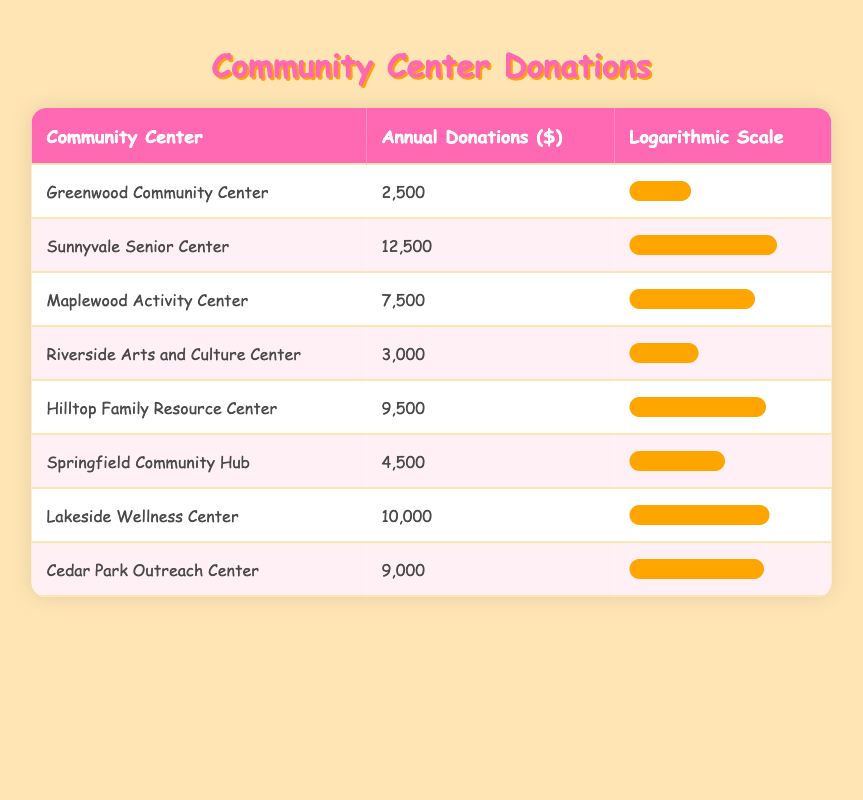What is the annual donation amount for the Sunnyvale Senior Center? The table explicitly lists the Sunnyvale Senior Center with an annual donation of 12,500 dollars
Answer: 12,500 Which community center received the least annual donations? The Greenwood Community Center has the lowest annual donation amount in the table, which is 2,500 dollars
Answer: 2,500 What is the total annual donations received by all the community centers? To calculate the total, we sum up the annual donations: 2,500 + 12,500 + 7,500 + 3,000 + 9,500 + 4,500 + 10,000 + 9,000 = 58,500 dollars
Answer: 58,500 Is the Riverside Arts and Culture Center's annual donation greater than or equal to the Cedar Park Outreach Center's donations? Riverside Arts and Culture Center received 3,000 dollars while Cedar Park Outreach Center received 9,000 dollars, so the statement is false
Answer: No What is the average annual donation of the community centers? To find the average, we first sum the annual donations (58,500) and divide by the number of community centers (8). Therefore, 58,500 / 8 = 7,312.5 dollars
Answer: 7,312.5 Which community center has donations closest to the average? The average is 7,312.5 dollars; comparing each center's donations, Maplewood Activity Center at 7,500 dollars is closest
Answer: Maplewood Activity Center How much more did Lakeside Wellness Center receive than Riverside Arts and Culture Center? Lakeside Wellness Center received 10,000 dollars and Riverside Arts and Culture Center received 3,000 dollars. The difference is 10,000 - 3,000 = 7,000 dollars
Answer: 7,000 Did any community center receive more than 10,000 dollars in donations? According to the table, only the Sunnyvale Senior Center received 12,500 dollars, which is more than 10,000 dollars
Answer: Yes 